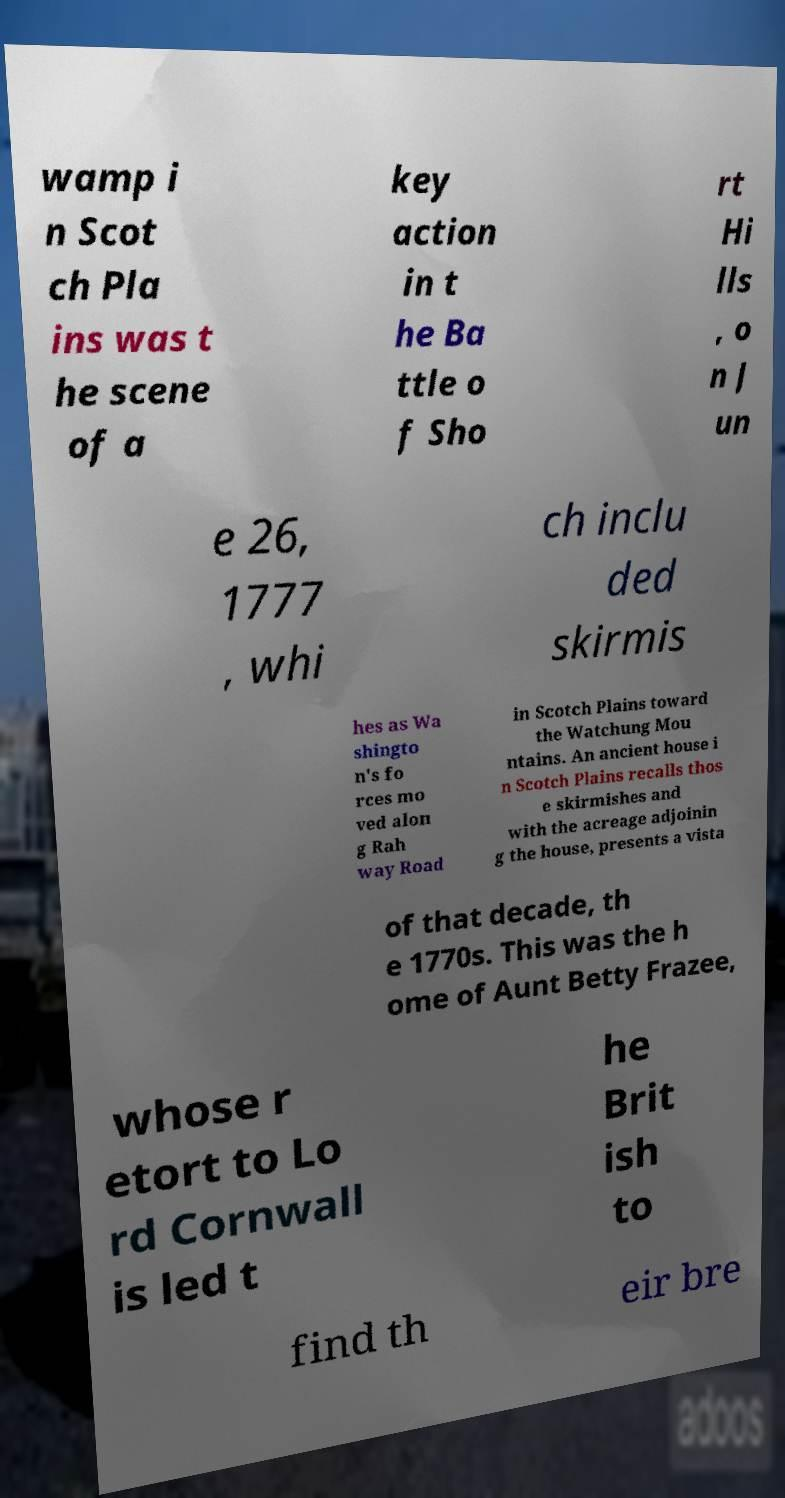There's text embedded in this image that I need extracted. Can you transcribe it verbatim? wamp i n Scot ch Pla ins was t he scene of a key action in t he Ba ttle o f Sho rt Hi lls , o n J un e 26, 1777 , whi ch inclu ded skirmis hes as Wa shingto n's fo rces mo ved alon g Rah way Road in Scotch Plains toward the Watchung Mou ntains. An ancient house i n Scotch Plains recalls thos e skirmishes and with the acreage adjoinin g the house, presents a vista of that decade, th e 1770s. This was the h ome of Aunt Betty Frazee, whose r etort to Lo rd Cornwall is led t he Brit ish to find th eir bre 